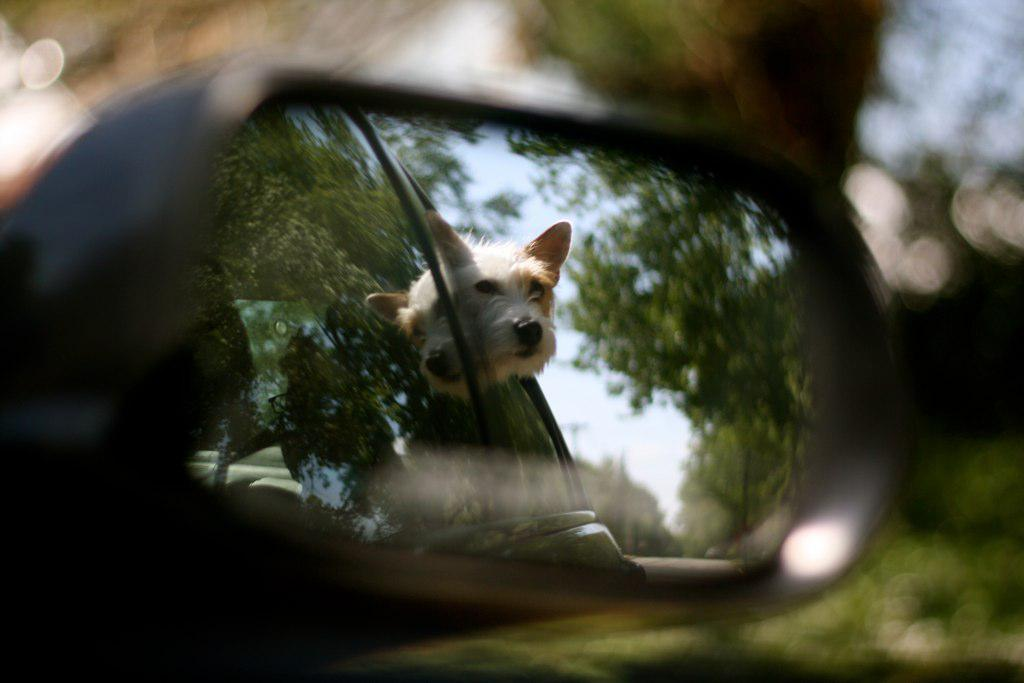What animal is present in the image? There is a dog in the image. Where is the dog located in relation to another object? The dog is in front of a mirror. What type of surface is visible in the image? There is grass on the surface in the image. What type of blade is being used by the person in the image? There is no person present in the image, and therefore no blade being used. 